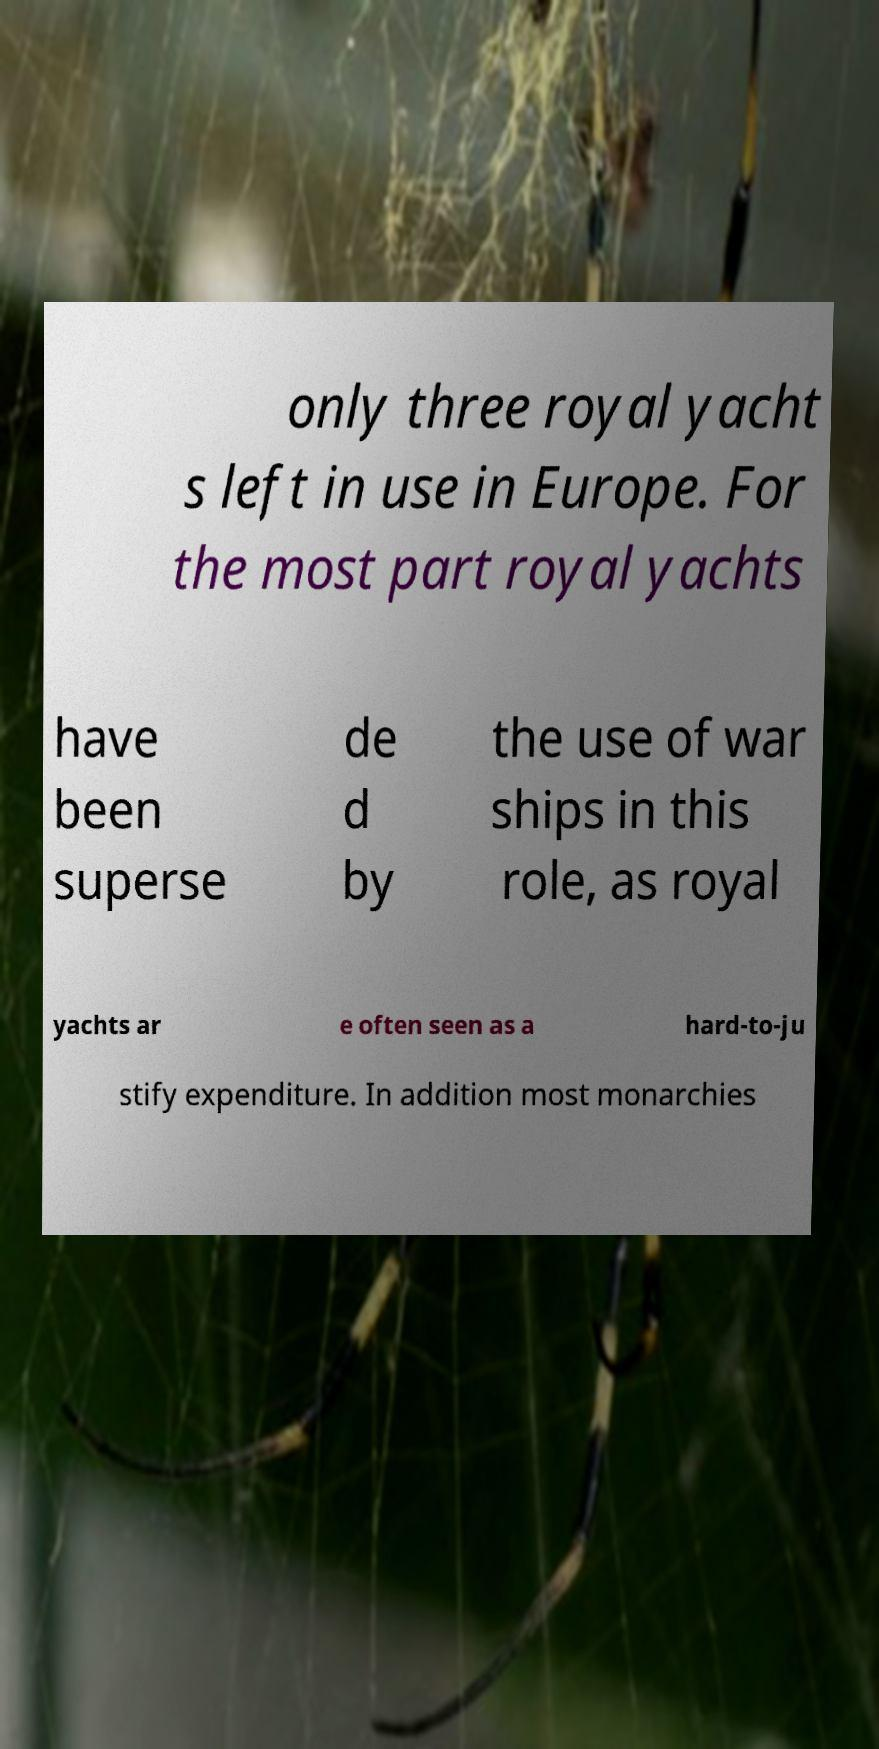There's text embedded in this image that I need extracted. Can you transcribe it verbatim? only three royal yacht s left in use in Europe. For the most part royal yachts have been superse de d by the use of war ships in this role, as royal yachts ar e often seen as a hard-to-ju stify expenditure. In addition most monarchies 